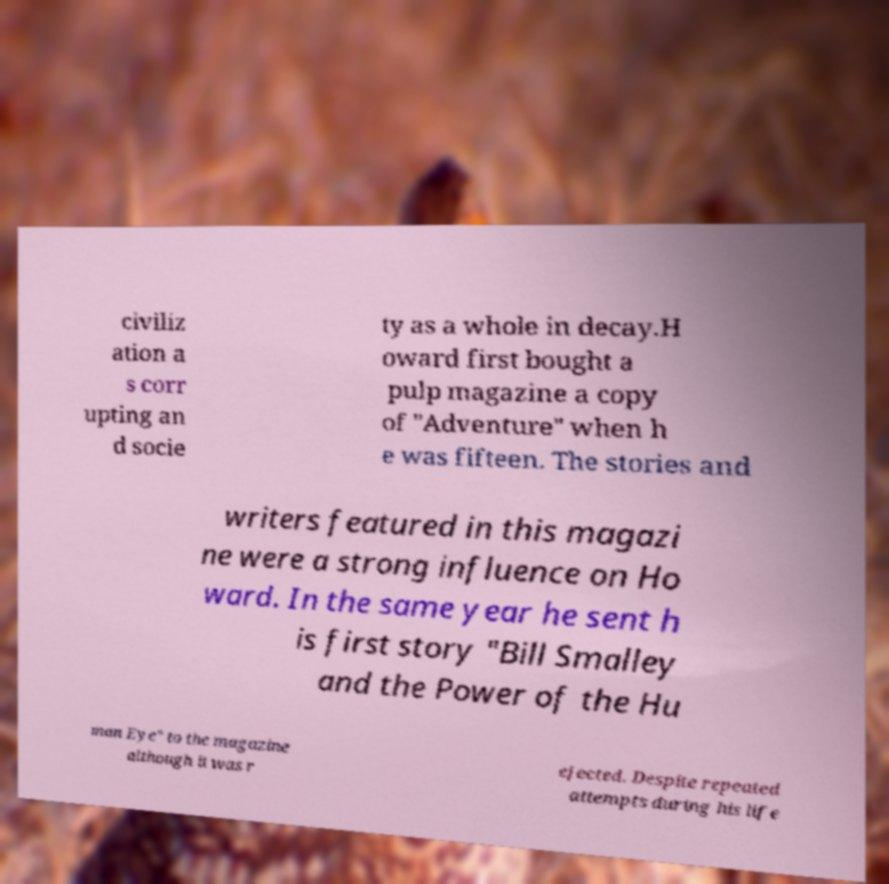Could you extract and type out the text from this image? civiliz ation a s corr upting an d socie ty as a whole in decay.H oward first bought a pulp magazine a copy of "Adventure" when h e was fifteen. The stories and writers featured in this magazi ne were a strong influence on Ho ward. In the same year he sent h is first story "Bill Smalley and the Power of the Hu man Eye" to the magazine although it was r ejected. Despite repeated attempts during his life 